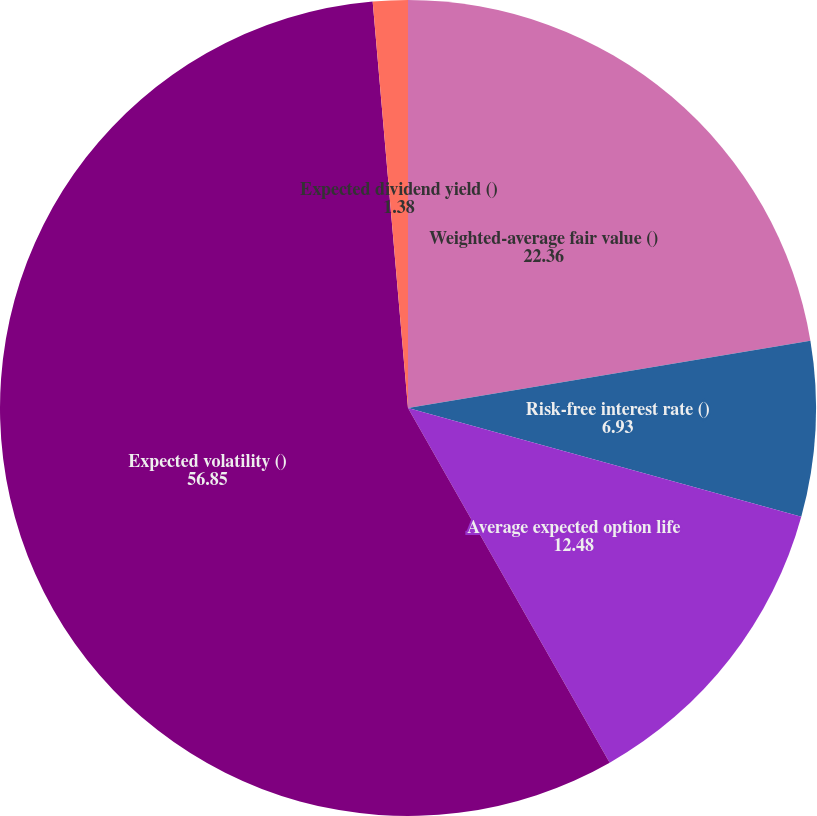Convert chart. <chart><loc_0><loc_0><loc_500><loc_500><pie_chart><fcel>Weighted-average fair value ()<fcel>Risk-free interest rate ()<fcel>Average expected option life<fcel>Expected volatility ()<fcel>Expected dividend yield ()<nl><fcel>22.36%<fcel>6.93%<fcel>12.48%<fcel>56.85%<fcel>1.38%<nl></chart> 